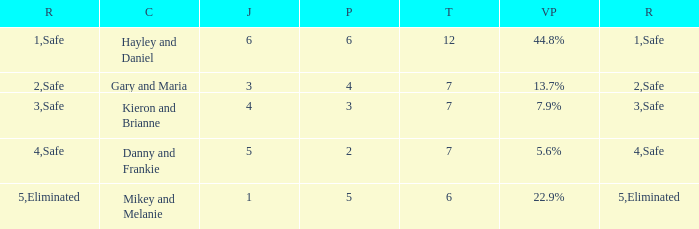What was the total number when the vote percentage was 44.8%? 1.0. 